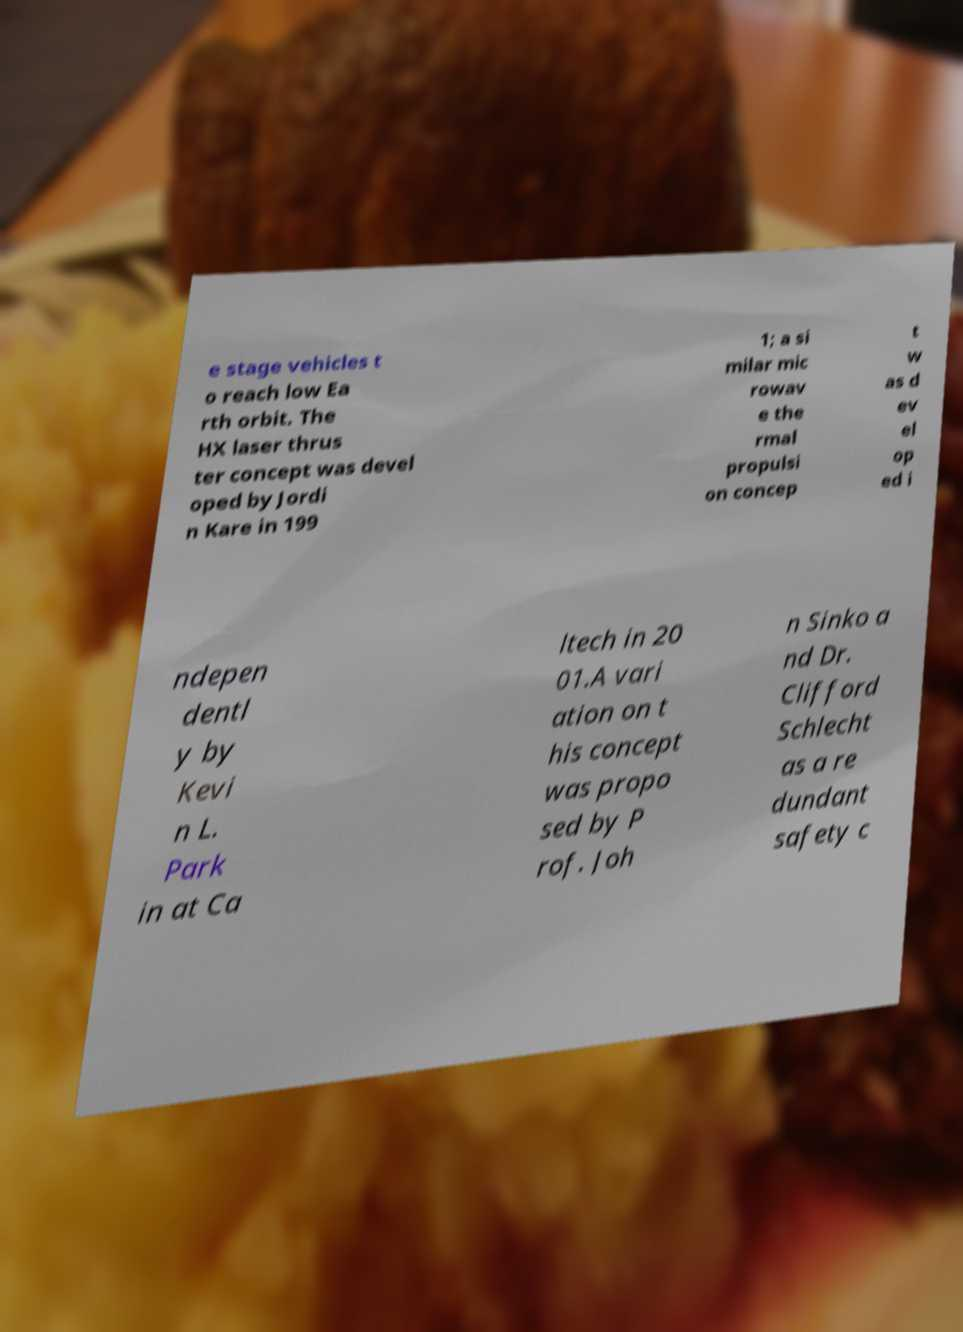Could you assist in decoding the text presented in this image and type it out clearly? e stage vehicles t o reach low Ea rth orbit. The HX laser thrus ter concept was devel oped by Jordi n Kare in 199 1; a si milar mic rowav e the rmal propulsi on concep t w as d ev el op ed i ndepen dentl y by Kevi n L. Park in at Ca ltech in 20 01.A vari ation on t his concept was propo sed by P rof. Joh n Sinko a nd Dr. Clifford Schlecht as a re dundant safety c 